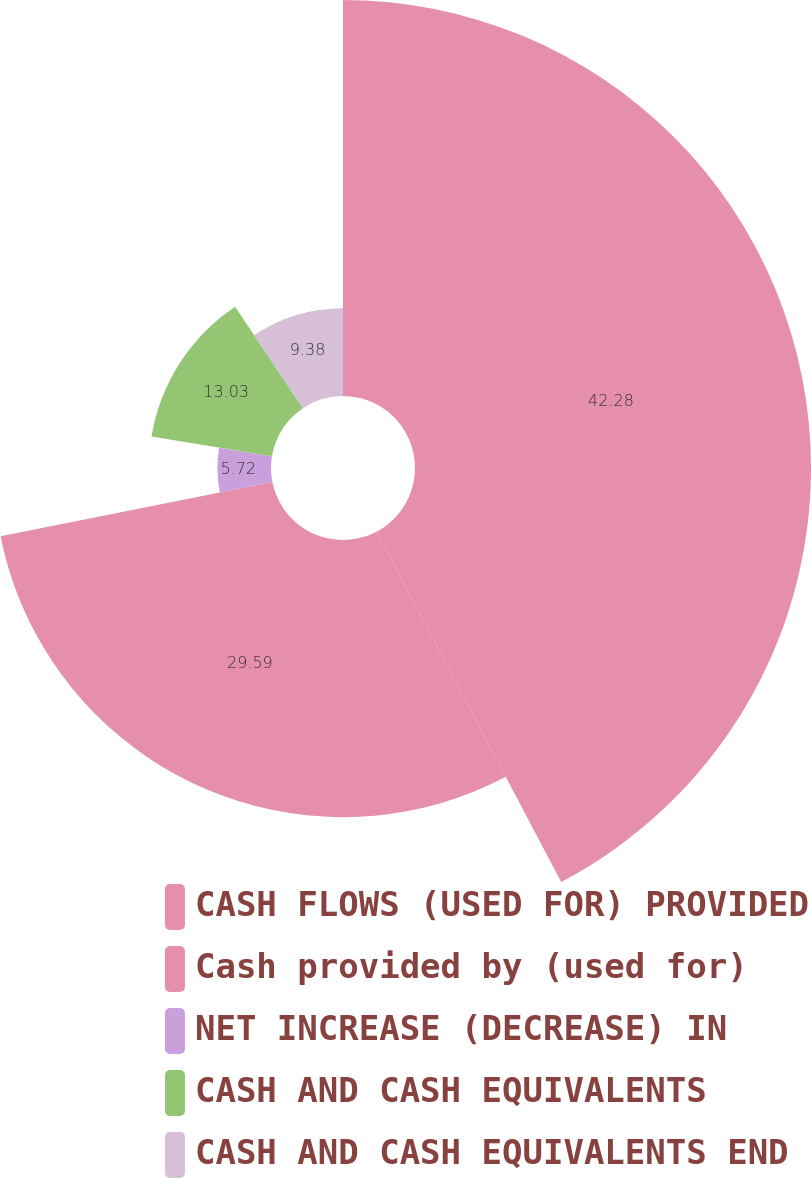<chart> <loc_0><loc_0><loc_500><loc_500><pie_chart><fcel>CASH FLOWS (USED FOR) PROVIDED<fcel>Cash provided by (used for)<fcel>NET INCREASE (DECREASE) IN<fcel>CASH AND CASH EQUIVALENTS<fcel>CASH AND CASH EQUIVALENTS END<nl><fcel>42.28%<fcel>29.59%<fcel>5.72%<fcel>13.03%<fcel>9.38%<nl></chart> 